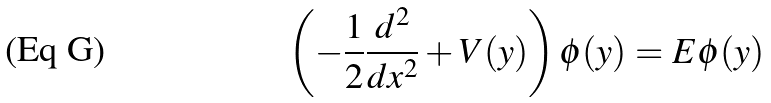Convert formula to latex. <formula><loc_0><loc_0><loc_500><loc_500>\left ( - \frac { 1 } { 2 } \frac { d ^ { 2 } } { d x ^ { 2 } } + V ( y ) \right ) \phi ( y ) = E \phi ( y )</formula> 